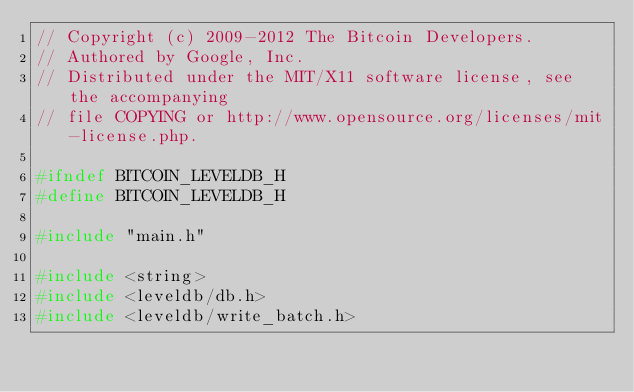Convert code to text. <code><loc_0><loc_0><loc_500><loc_500><_C_>// Copyright (c) 2009-2012 The Bitcoin Developers.
// Authored by Google, Inc.
// Distributed under the MIT/X11 software license, see the accompanying
// file COPYING or http://www.opensource.org/licenses/mit-license.php.

#ifndef BITCOIN_LEVELDB_H
#define BITCOIN_LEVELDB_H

#include "main.h"

#include <string>
#include <leveldb/db.h>
#include <leveldb/write_batch.h>
</code> 